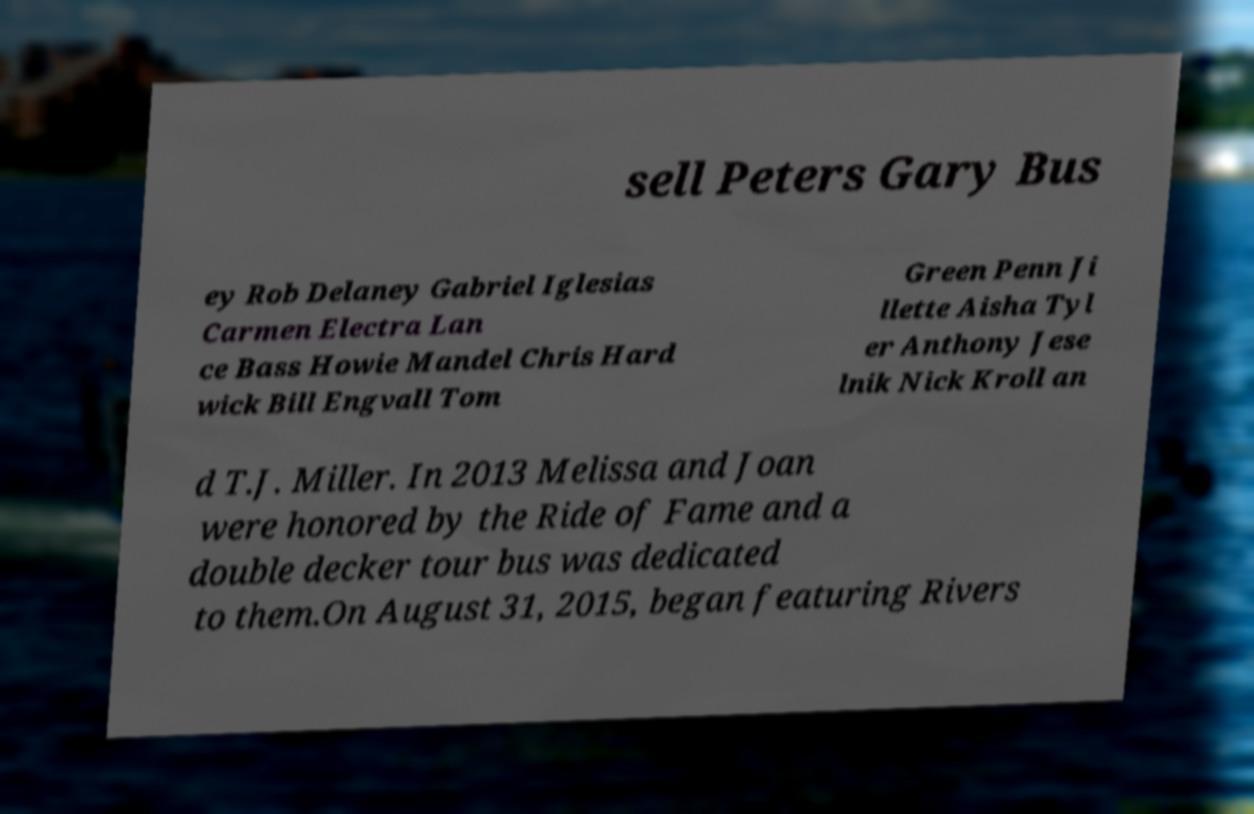Could you assist in decoding the text presented in this image and type it out clearly? sell Peters Gary Bus ey Rob Delaney Gabriel Iglesias Carmen Electra Lan ce Bass Howie Mandel Chris Hard wick Bill Engvall Tom Green Penn Ji llette Aisha Tyl er Anthony Jese lnik Nick Kroll an d T.J. Miller. In 2013 Melissa and Joan were honored by the Ride of Fame and a double decker tour bus was dedicated to them.On August 31, 2015, began featuring Rivers 